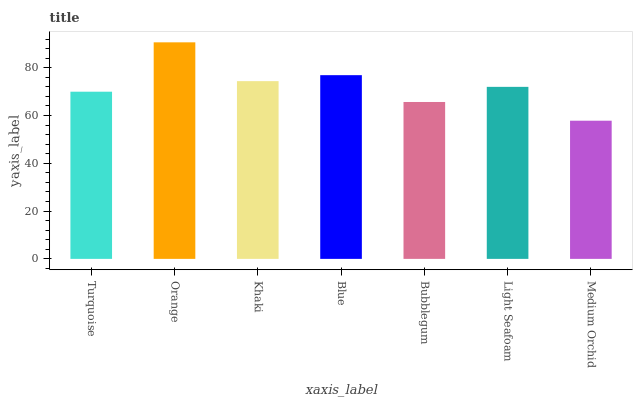Is Medium Orchid the minimum?
Answer yes or no. Yes. Is Orange the maximum?
Answer yes or no. Yes. Is Khaki the minimum?
Answer yes or no. No. Is Khaki the maximum?
Answer yes or no. No. Is Orange greater than Khaki?
Answer yes or no. Yes. Is Khaki less than Orange?
Answer yes or no. Yes. Is Khaki greater than Orange?
Answer yes or no. No. Is Orange less than Khaki?
Answer yes or no. No. Is Light Seafoam the high median?
Answer yes or no. Yes. Is Light Seafoam the low median?
Answer yes or no. Yes. Is Khaki the high median?
Answer yes or no. No. Is Bubblegum the low median?
Answer yes or no. No. 